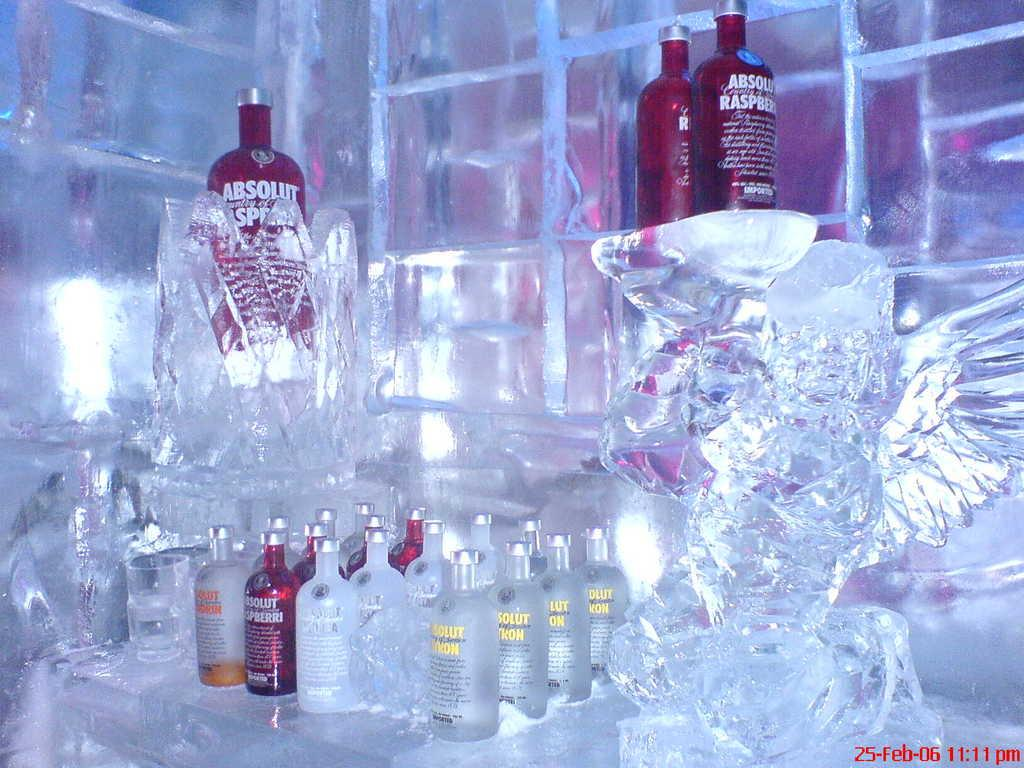<image>
Present a compact description of the photo's key features. An ice sculpture with several bottles of Absolut Vodka next to it. 